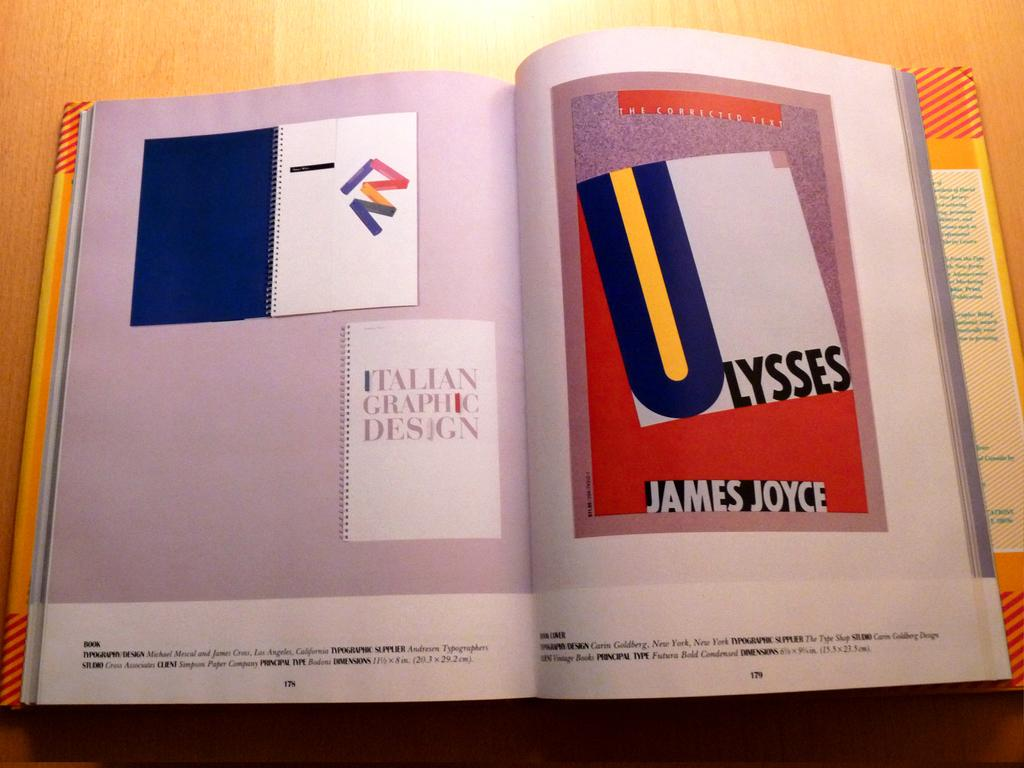<image>
Provide a brief description of the given image. A book is opened to show a cover design of ULYSSES. 